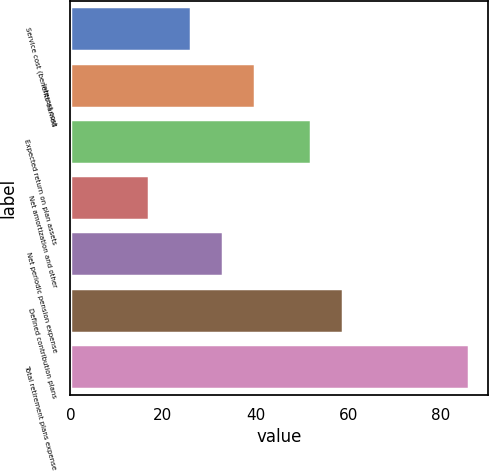Convert chart to OTSL. <chart><loc_0><loc_0><loc_500><loc_500><bar_chart><fcel>Service cost (benefits earned<fcel>Interest cost<fcel>Expected return on plan assets<fcel>Net amortization and other<fcel>Net periodic pension expense<fcel>Defined contribution plans<fcel>Total retirement plans expense<nl><fcel>26<fcel>39.8<fcel>52<fcel>17<fcel>32.9<fcel>58.9<fcel>86<nl></chart> 